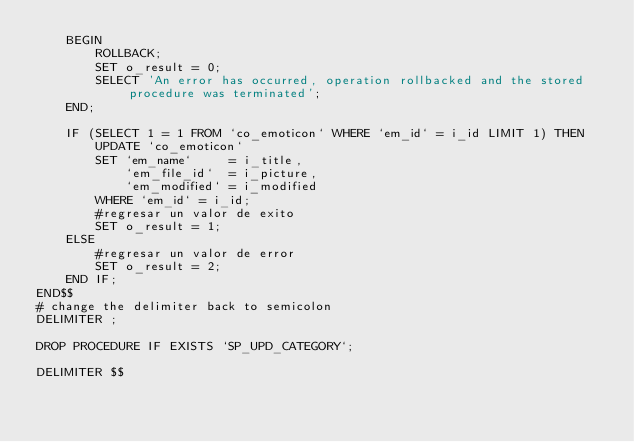Convert code to text. <code><loc_0><loc_0><loc_500><loc_500><_SQL_>    BEGIN
        ROLLBACK;
        SET o_result = 0;
        SELECT 'An error has occurred, operation rollbacked and the stored procedure was terminated';
    END;

    IF (SELECT 1 = 1 FROM `co_emoticon` WHERE `em_id` = i_id LIMIT 1) THEN
        UPDATE `co_emoticon`
        SET `em_name`     = i_title,
            `em_file_id`  = i_picture,
            `em_modified` = i_modified
        WHERE `em_id` = i_id;
        #regresar un valor de exito
        SET o_result = 1;
    ELSE
        #regresar un valor de error
        SET o_result = 2;
    END IF;
END$$
# change the delimiter back to semicolon
DELIMITER ;

DROP PROCEDURE IF EXISTS `SP_UPD_CATEGORY`;

DELIMITER $$</code> 